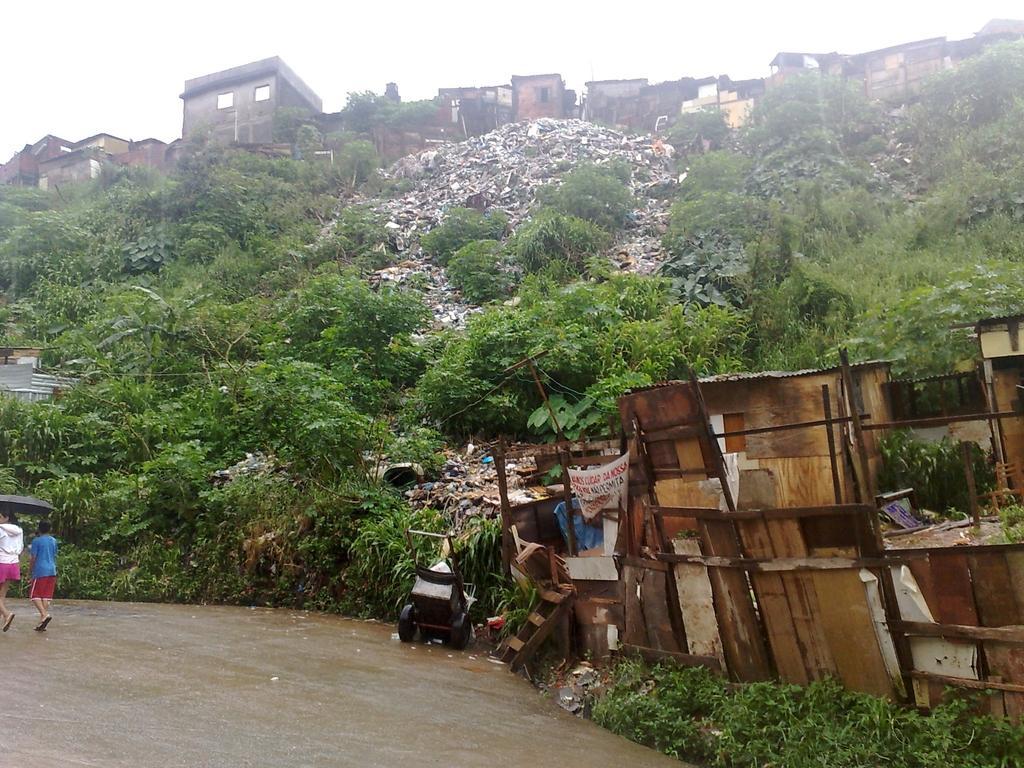Can you describe this image briefly? In this image I can see the road. On the road there are two people with black color umbrella and these people are wearing the different color dresses. To the side I can see wooden objects and I can also see the wheel chair on the road. In the back there are many trees, houses and the sky. 